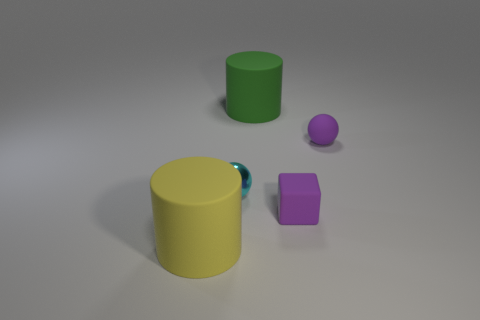What can you infer about the function of these objects? Since the objects lack any additional context or complex features, they seem to be simple geometric shapes, potentially for demonstration or educational purposes related to geometry, volume, or spatial design. They don't seem to represent any tools or containers that would imply a specific practical function. 